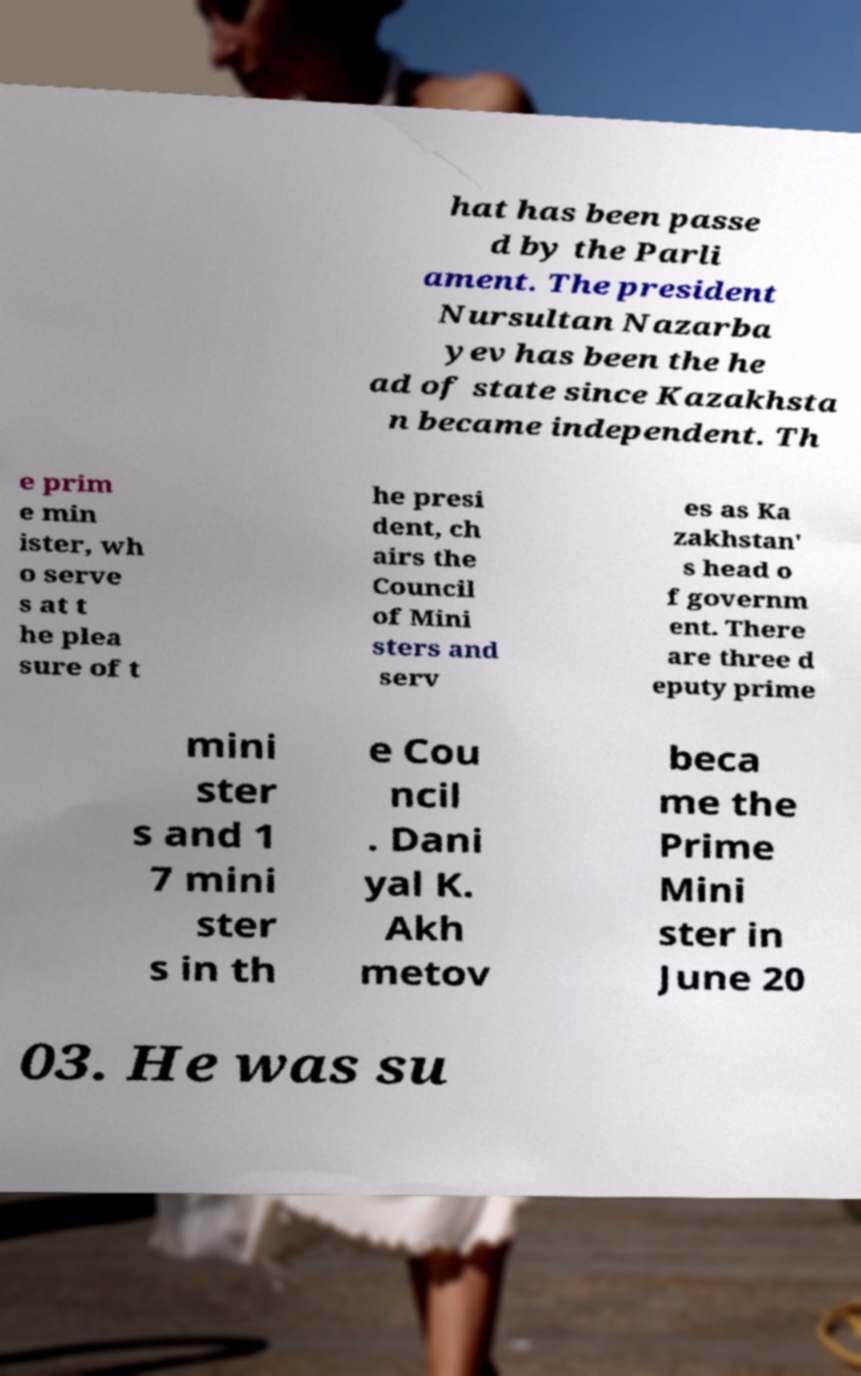Could you extract and type out the text from this image? hat has been passe d by the Parli ament. The president Nursultan Nazarba yev has been the he ad of state since Kazakhsta n became independent. Th e prim e min ister, wh o serve s at t he plea sure of t he presi dent, ch airs the Council of Mini sters and serv es as Ka zakhstan' s head o f governm ent. There are three d eputy prime mini ster s and 1 7 mini ster s in th e Cou ncil . Dani yal K. Akh metov beca me the Prime Mini ster in June 20 03. He was su 